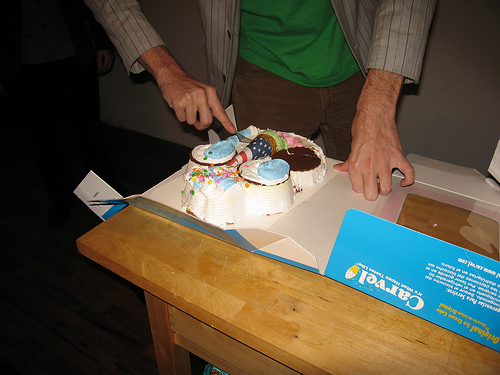Describe the cake in the picture. The cake in the picture is round with white frosting. It's adorned with a variety of colorful decorations, including what appear to be sprinkles and possibly candles, suggesting it's for a festive occasion. Can you tell me more about the decorations on the cake? Certainly! On top of the cake, there are vibrant, multicolored sprinkles scattered about, adding a playful touch. It looks like there might be a few candles that have been placed for the celebrant to blow out, which is a common tradition for birthdays. 